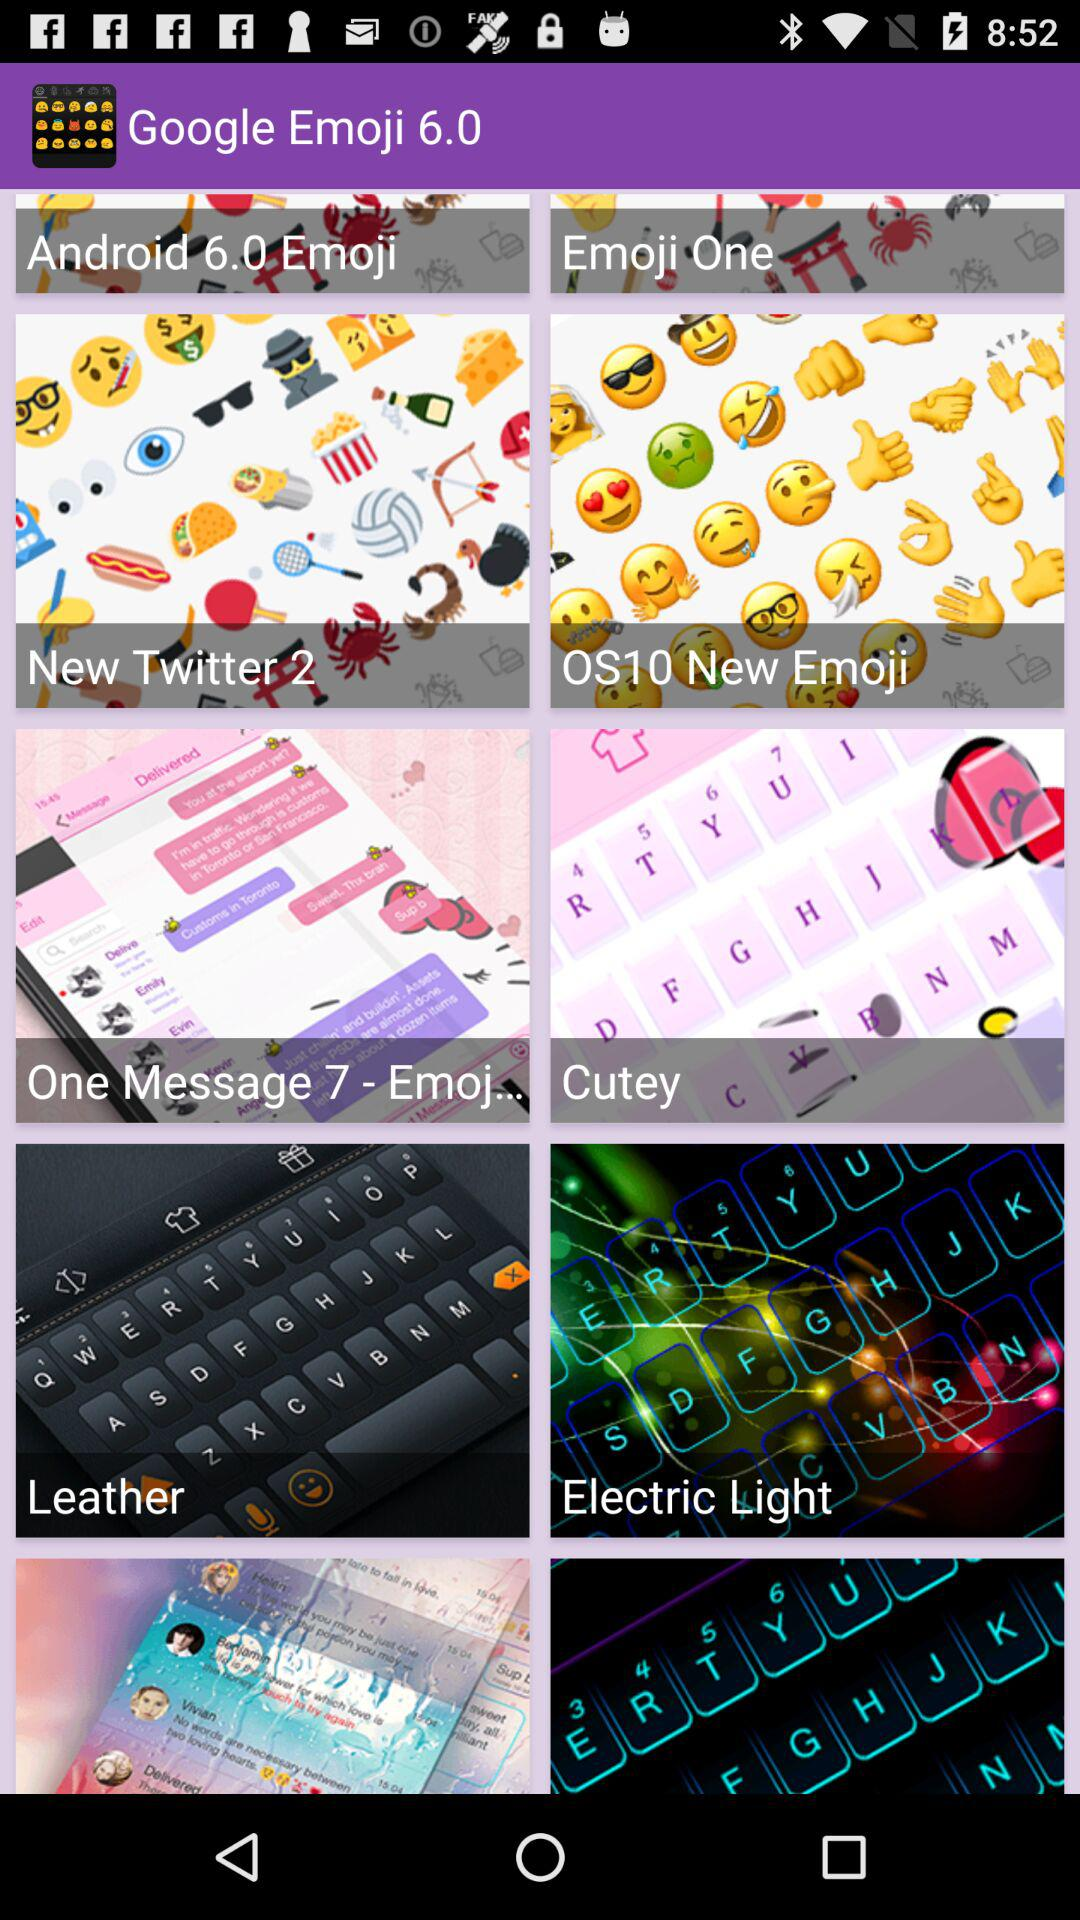What are the different categories of Emojis shown? The different categories are "Android 6.0 Emoji", "Emoji One", "New Twitter 2", "OS10 New Emoji", "One Message 7 - Emoj...", "Cutey", "Leather" and "Electric Light". 